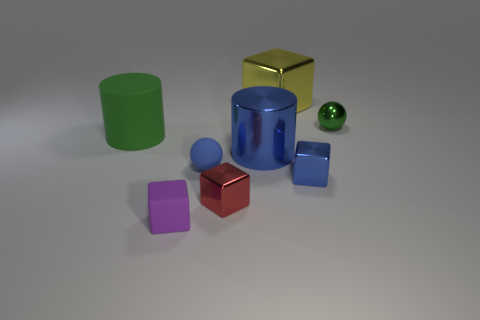Are there more tiny green objects in front of the blue metallic block than tiny brown rubber cylinders?
Ensure brevity in your answer.  No. Does the yellow thing have the same shape as the large green object?
Make the answer very short. No. What number of green cylinders are the same material as the yellow cube?
Your answer should be very brief. 0. What is the size of the metal object that is the same shape as the tiny blue rubber object?
Give a very brief answer. Small. Do the purple block and the blue matte thing have the same size?
Keep it short and to the point. Yes. There is a tiny rubber thing that is right of the block in front of the tiny metallic cube to the left of the large blue object; what shape is it?
Provide a short and direct response. Sphere. What color is the tiny rubber thing that is the same shape as the yellow shiny thing?
Your answer should be compact. Purple. What size is the rubber thing that is both to the left of the matte ball and in front of the large blue metallic thing?
Provide a short and direct response. Small. There is a small green sphere to the right of the small ball that is left of the green metal thing; what number of small things are in front of it?
Provide a succinct answer. 4. What number of tiny objects are either blue objects or yellow shiny cubes?
Make the answer very short. 2. 